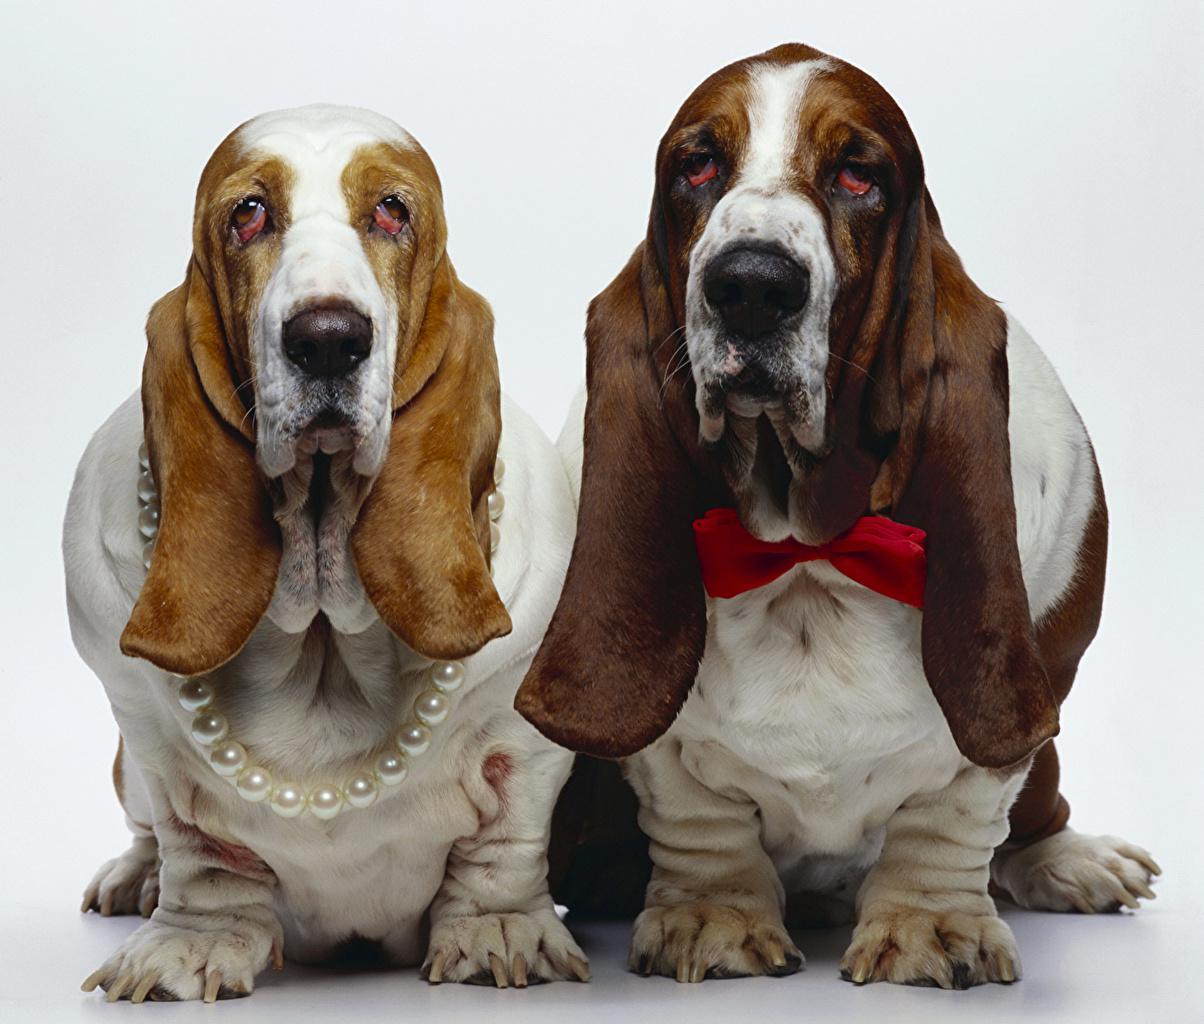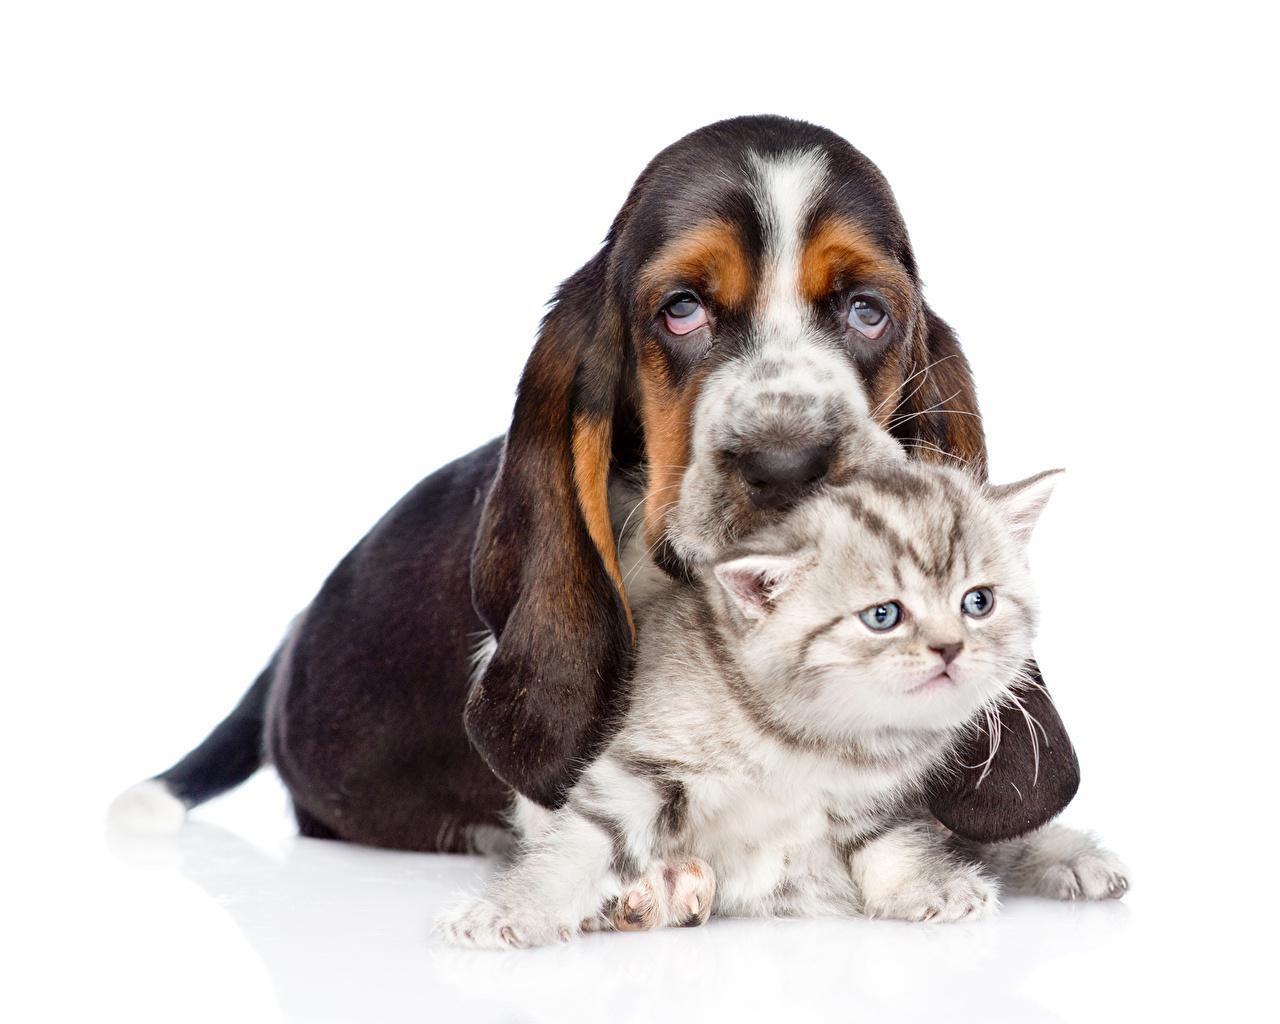The first image is the image on the left, the second image is the image on the right. Evaluate the accuracy of this statement regarding the images: "There are no more than two dogs.". Is it true? Answer yes or no. No. The first image is the image on the left, the second image is the image on the right. Considering the images on both sides, is "Each image contains the same number of animals and contains more than one animal." valid? Answer yes or no. Yes. 